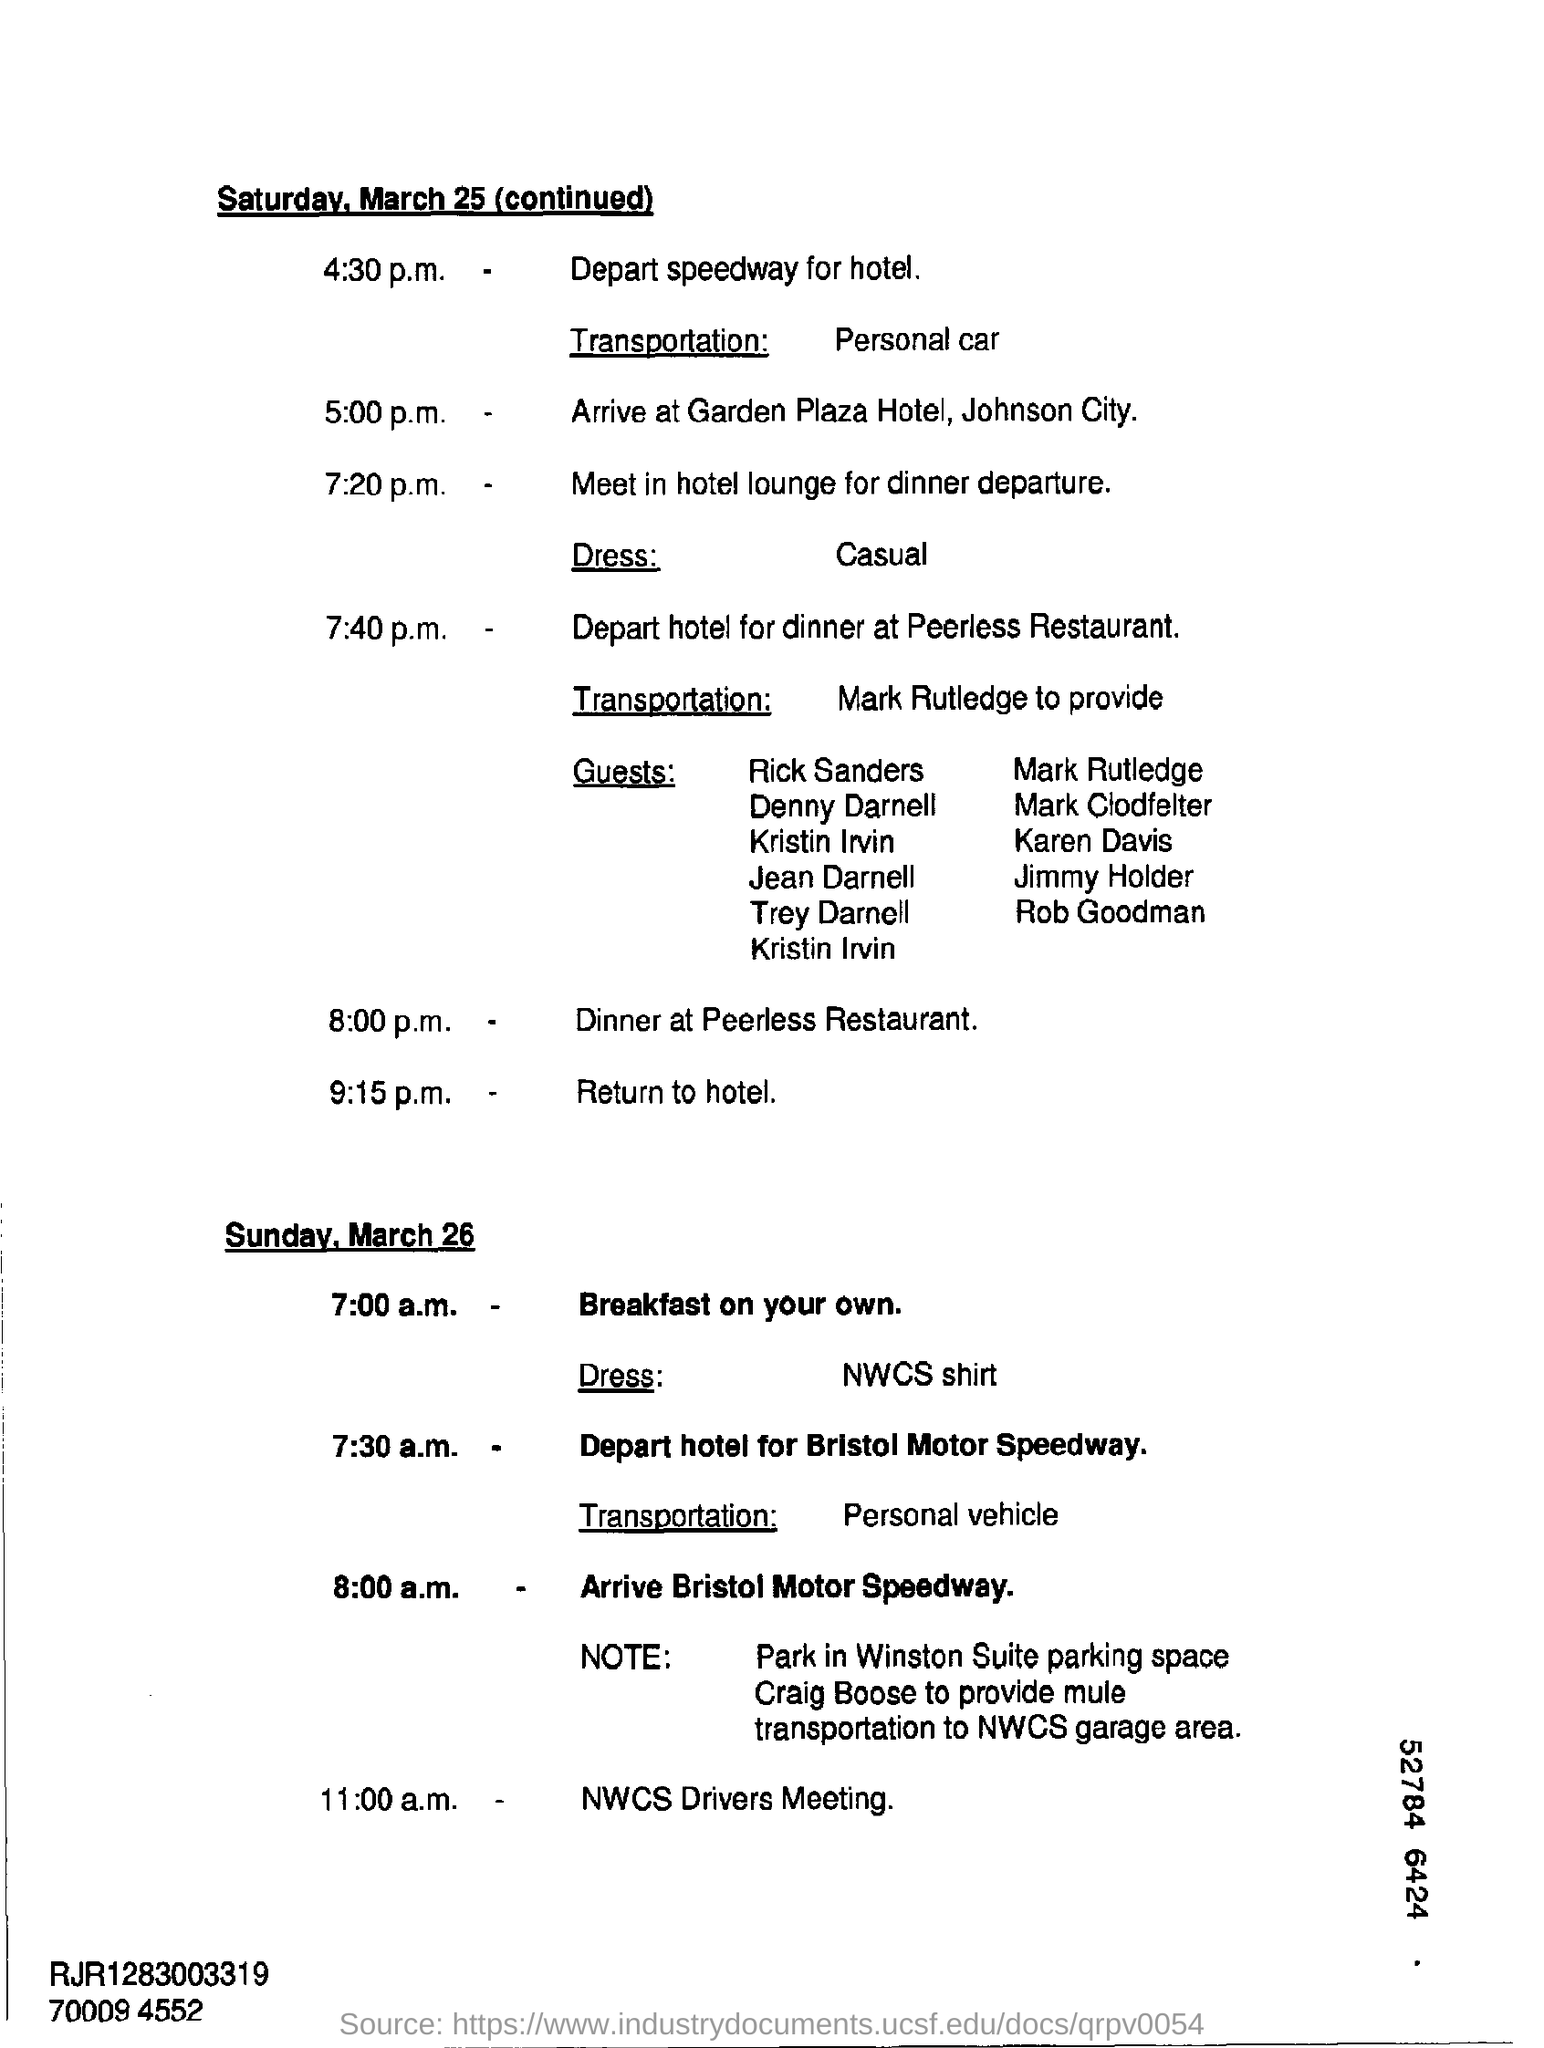List a handful of essential elements in this visual. The meeting at 11:00 a.m. is a NWCS Divers Meeting. It was mentioned that a casual dress would be appropriate for dinner departure. At 8:00 p.m., the location of the dinner is the Peerless Restaurant. The time to arrive at the Garden Plaza Hotel was 5:00 p.m. At 4:30 pm on Saturday, it is mentioned that personal car will be used for transportation. 